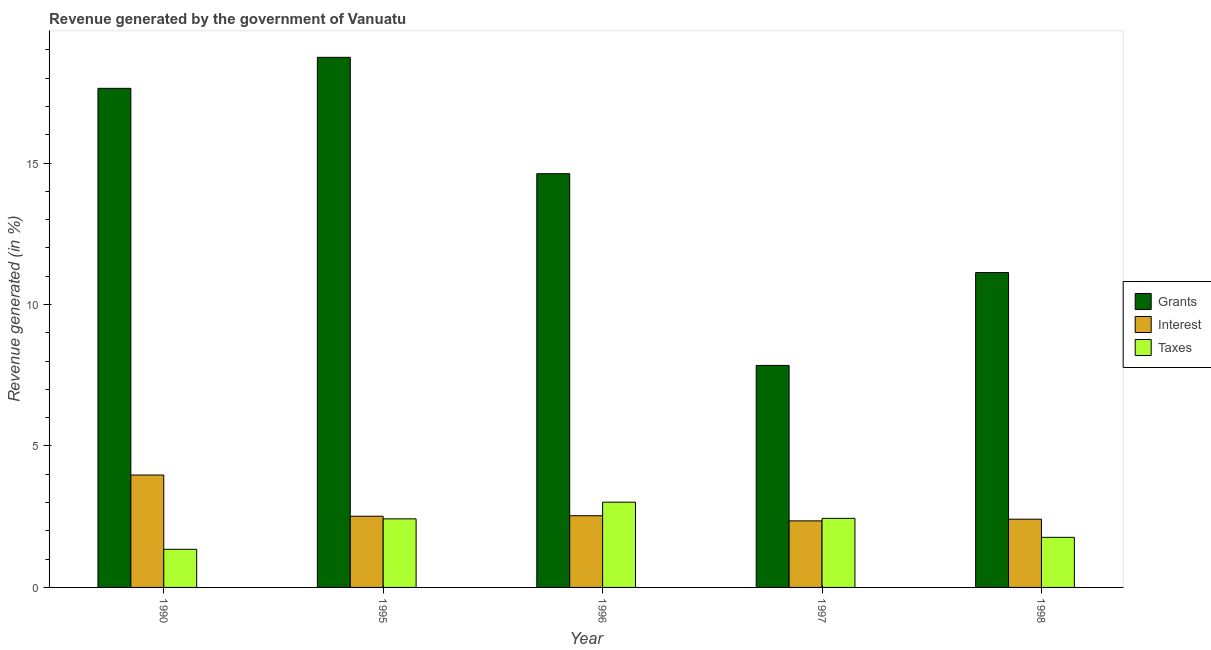Are the number of bars per tick equal to the number of legend labels?
Your answer should be very brief. Yes. How many bars are there on the 3rd tick from the left?
Give a very brief answer. 3. What is the label of the 5th group of bars from the left?
Your response must be concise. 1998. In how many cases, is the number of bars for a given year not equal to the number of legend labels?
Keep it short and to the point. 0. What is the percentage of revenue generated by grants in 1997?
Keep it short and to the point. 7.85. Across all years, what is the maximum percentage of revenue generated by interest?
Keep it short and to the point. 3.97. Across all years, what is the minimum percentage of revenue generated by interest?
Your answer should be compact. 2.35. In which year was the percentage of revenue generated by grants maximum?
Your answer should be compact. 1995. In which year was the percentage of revenue generated by interest minimum?
Your response must be concise. 1997. What is the total percentage of revenue generated by interest in the graph?
Your response must be concise. 13.79. What is the difference between the percentage of revenue generated by grants in 1990 and that in 1996?
Give a very brief answer. 3.02. What is the difference between the percentage of revenue generated by interest in 1998 and the percentage of revenue generated by grants in 1990?
Make the answer very short. -1.56. What is the average percentage of revenue generated by interest per year?
Your answer should be compact. 2.76. In the year 1990, what is the difference between the percentage of revenue generated by taxes and percentage of revenue generated by grants?
Your answer should be very brief. 0. In how many years, is the percentage of revenue generated by interest greater than 18 %?
Offer a terse response. 0. What is the ratio of the percentage of revenue generated by grants in 1997 to that in 1998?
Offer a very short reply. 0.71. Is the difference between the percentage of revenue generated by taxes in 1997 and 1998 greater than the difference between the percentage of revenue generated by grants in 1997 and 1998?
Provide a succinct answer. No. What is the difference between the highest and the second highest percentage of revenue generated by taxes?
Your answer should be compact. 0.57. What is the difference between the highest and the lowest percentage of revenue generated by interest?
Provide a short and direct response. 1.62. In how many years, is the percentage of revenue generated by grants greater than the average percentage of revenue generated by grants taken over all years?
Ensure brevity in your answer.  3. What does the 2nd bar from the left in 1995 represents?
Ensure brevity in your answer.  Interest. What does the 3rd bar from the right in 1990 represents?
Provide a short and direct response. Grants. Is it the case that in every year, the sum of the percentage of revenue generated by grants and percentage of revenue generated by interest is greater than the percentage of revenue generated by taxes?
Give a very brief answer. Yes. Are all the bars in the graph horizontal?
Provide a succinct answer. No. How many years are there in the graph?
Give a very brief answer. 5. What is the difference between two consecutive major ticks on the Y-axis?
Your answer should be compact. 5. Are the values on the major ticks of Y-axis written in scientific E-notation?
Give a very brief answer. No. Does the graph contain grids?
Provide a short and direct response. No. How many legend labels are there?
Your response must be concise. 3. What is the title of the graph?
Ensure brevity in your answer.  Revenue generated by the government of Vanuatu. What is the label or title of the X-axis?
Your answer should be very brief. Year. What is the label or title of the Y-axis?
Provide a succinct answer. Revenue generated (in %). What is the Revenue generated (in %) of Grants in 1990?
Provide a short and direct response. 17.64. What is the Revenue generated (in %) of Interest in 1990?
Your response must be concise. 3.97. What is the Revenue generated (in %) in Taxes in 1990?
Give a very brief answer. 1.35. What is the Revenue generated (in %) of Grants in 1995?
Ensure brevity in your answer.  18.74. What is the Revenue generated (in %) of Interest in 1995?
Your response must be concise. 2.52. What is the Revenue generated (in %) in Taxes in 1995?
Your response must be concise. 2.42. What is the Revenue generated (in %) in Grants in 1996?
Your response must be concise. 14.63. What is the Revenue generated (in %) in Interest in 1996?
Provide a succinct answer. 2.53. What is the Revenue generated (in %) of Taxes in 1996?
Your answer should be very brief. 3.01. What is the Revenue generated (in %) in Grants in 1997?
Provide a short and direct response. 7.85. What is the Revenue generated (in %) of Interest in 1997?
Ensure brevity in your answer.  2.35. What is the Revenue generated (in %) of Taxes in 1997?
Your answer should be compact. 2.44. What is the Revenue generated (in %) in Grants in 1998?
Make the answer very short. 11.13. What is the Revenue generated (in %) in Interest in 1998?
Make the answer very short. 2.41. What is the Revenue generated (in %) in Taxes in 1998?
Provide a short and direct response. 1.77. Across all years, what is the maximum Revenue generated (in %) in Grants?
Your answer should be very brief. 18.74. Across all years, what is the maximum Revenue generated (in %) of Interest?
Keep it short and to the point. 3.97. Across all years, what is the maximum Revenue generated (in %) in Taxes?
Your answer should be very brief. 3.01. Across all years, what is the minimum Revenue generated (in %) of Grants?
Provide a short and direct response. 7.85. Across all years, what is the minimum Revenue generated (in %) in Interest?
Provide a succinct answer. 2.35. Across all years, what is the minimum Revenue generated (in %) of Taxes?
Give a very brief answer. 1.35. What is the total Revenue generated (in %) in Grants in the graph?
Your answer should be very brief. 69.99. What is the total Revenue generated (in %) in Interest in the graph?
Provide a short and direct response. 13.79. What is the total Revenue generated (in %) in Taxes in the graph?
Provide a succinct answer. 11. What is the difference between the Revenue generated (in %) of Grants in 1990 and that in 1995?
Your answer should be compact. -1.1. What is the difference between the Revenue generated (in %) in Interest in 1990 and that in 1995?
Your answer should be very brief. 1.46. What is the difference between the Revenue generated (in %) of Taxes in 1990 and that in 1995?
Make the answer very short. -1.08. What is the difference between the Revenue generated (in %) in Grants in 1990 and that in 1996?
Make the answer very short. 3.02. What is the difference between the Revenue generated (in %) in Interest in 1990 and that in 1996?
Ensure brevity in your answer.  1.44. What is the difference between the Revenue generated (in %) in Taxes in 1990 and that in 1996?
Keep it short and to the point. -1.67. What is the difference between the Revenue generated (in %) of Grants in 1990 and that in 1997?
Provide a short and direct response. 9.8. What is the difference between the Revenue generated (in %) of Interest in 1990 and that in 1997?
Provide a succinct answer. 1.62. What is the difference between the Revenue generated (in %) in Taxes in 1990 and that in 1997?
Provide a short and direct response. -1.09. What is the difference between the Revenue generated (in %) of Grants in 1990 and that in 1998?
Provide a short and direct response. 6.51. What is the difference between the Revenue generated (in %) of Interest in 1990 and that in 1998?
Your answer should be compact. 1.56. What is the difference between the Revenue generated (in %) of Taxes in 1990 and that in 1998?
Offer a terse response. -0.42. What is the difference between the Revenue generated (in %) of Grants in 1995 and that in 1996?
Give a very brief answer. 4.11. What is the difference between the Revenue generated (in %) of Interest in 1995 and that in 1996?
Your answer should be compact. -0.02. What is the difference between the Revenue generated (in %) of Taxes in 1995 and that in 1996?
Make the answer very short. -0.59. What is the difference between the Revenue generated (in %) of Grants in 1995 and that in 1997?
Your response must be concise. 10.89. What is the difference between the Revenue generated (in %) in Interest in 1995 and that in 1997?
Provide a succinct answer. 0.16. What is the difference between the Revenue generated (in %) in Taxes in 1995 and that in 1997?
Offer a very short reply. -0.02. What is the difference between the Revenue generated (in %) in Grants in 1995 and that in 1998?
Keep it short and to the point. 7.61. What is the difference between the Revenue generated (in %) in Interest in 1995 and that in 1998?
Ensure brevity in your answer.  0.11. What is the difference between the Revenue generated (in %) in Taxes in 1995 and that in 1998?
Offer a terse response. 0.65. What is the difference between the Revenue generated (in %) of Grants in 1996 and that in 1997?
Your answer should be very brief. 6.78. What is the difference between the Revenue generated (in %) of Interest in 1996 and that in 1997?
Keep it short and to the point. 0.18. What is the difference between the Revenue generated (in %) in Taxes in 1996 and that in 1997?
Give a very brief answer. 0.57. What is the difference between the Revenue generated (in %) of Grants in 1996 and that in 1998?
Ensure brevity in your answer.  3.49. What is the difference between the Revenue generated (in %) in Interest in 1996 and that in 1998?
Provide a succinct answer. 0.12. What is the difference between the Revenue generated (in %) of Taxes in 1996 and that in 1998?
Make the answer very short. 1.24. What is the difference between the Revenue generated (in %) in Grants in 1997 and that in 1998?
Keep it short and to the point. -3.28. What is the difference between the Revenue generated (in %) in Interest in 1997 and that in 1998?
Your answer should be compact. -0.06. What is the difference between the Revenue generated (in %) in Taxes in 1997 and that in 1998?
Your answer should be compact. 0.67. What is the difference between the Revenue generated (in %) of Grants in 1990 and the Revenue generated (in %) of Interest in 1995?
Ensure brevity in your answer.  15.13. What is the difference between the Revenue generated (in %) of Grants in 1990 and the Revenue generated (in %) of Taxes in 1995?
Offer a very short reply. 15.22. What is the difference between the Revenue generated (in %) of Interest in 1990 and the Revenue generated (in %) of Taxes in 1995?
Ensure brevity in your answer.  1.55. What is the difference between the Revenue generated (in %) in Grants in 1990 and the Revenue generated (in %) in Interest in 1996?
Provide a short and direct response. 15.11. What is the difference between the Revenue generated (in %) of Grants in 1990 and the Revenue generated (in %) of Taxes in 1996?
Provide a succinct answer. 14.63. What is the difference between the Revenue generated (in %) of Interest in 1990 and the Revenue generated (in %) of Taxes in 1996?
Offer a terse response. 0.96. What is the difference between the Revenue generated (in %) of Grants in 1990 and the Revenue generated (in %) of Interest in 1997?
Provide a succinct answer. 15.29. What is the difference between the Revenue generated (in %) of Grants in 1990 and the Revenue generated (in %) of Taxes in 1997?
Give a very brief answer. 15.2. What is the difference between the Revenue generated (in %) in Interest in 1990 and the Revenue generated (in %) in Taxes in 1997?
Ensure brevity in your answer.  1.53. What is the difference between the Revenue generated (in %) of Grants in 1990 and the Revenue generated (in %) of Interest in 1998?
Ensure brevity in your answer.  15.23. What is the difference between the Revenue generated (in %) of Grants in 1990 and the Revenue generated (in %) of Taxes in 1998?
Keep it short and to the point. 15.87. What is the difference between the Revenue generated (in %) of Interest in 1990 and the Revenue generated (in %) of Taxes in 1998?
Your response must be concise. 2.2. What is the difference between the Revenue generated (in %) in Grants in 1995 and the Revenue generated (in %) in Interest in 1996?
Your response must be concise. 16.21. What is the difference between the Revenue generated (in %) of Grants in 1995 and the Revenue generated (in %) of Taxes in 1996?
Ensure brevity in your answer.  15.73. What is the difference between the Revenue generated (in %) of Interest in 1995 and the Revenue generated (in %) of Taxes in 1996?
Offer a very short reply. -0.5. What is the difference between the Revenue generated (in %) of Grants in 1995 and the Revenue generated (in %) of Interest in 1997?
Give a very brief answer. 16.39. What is the difference between the Revenue generated (in %) in Grants in 1995 and the Revenue generated (in %) in Taxes in 1997?
Your answer should be compact. 16.3. What is the difference between the Revenue generated (in %) of Interest in 1995 and the Revenue generated (in %) of Taxes in 1997?
Give a very brief answer. 0.08. What is the difference between the Revenue generated (in %) in Grants in 1995 and the Revenue generated (in %) in Interest in 1998?
Give a very brief answer. 16.33. What is the difference between the Revenue generated (in %) in Grants in 1995 and the Revenue generated (in %) in Taxes in 1998?
Keep it short and to the point. 16.97. What is the difference between the Revenue generated (in %) of Interest in 1995 and the Revenue generated (in %) of Taxes in 1998?
Your answer should be compact. 0.75. What is the difference between the Revenue generated (in %) of Grants in 1996 and the Revenue generated (in %) of Interest in 1997?
Provide a short and direct response. 12.27. What is the difference between the Revenue generated (in %) in Grants in 1996 and the Revenue generated (in %) in Taxes in 1997?
Provide a succinct answer. 12.18. What is the difference between the Revenue generated (in %) of Interest in 1996 and the Revenue generated (in %) of Taxes in 1997?
Provide a short and direct response. 0.09. What is the difference between the Revenue generated (in %) in Grants in 1996 and the Revenue generated (in %) in Interest in 1998?
Provide a short and direct response. 12.21. What is the difference between the Revenue generated (in %) of Grants in 1996 and the Revenue generated (in %) of Taxes in 1998?
Give a very brief answer. 12.85. What is the difference between the Revenue generated (in %) in Interest in 1996 and the Revenue generated (in %) in Taxes in 1998?
Provide a short and direct response. 0.76. What is the difference between the Revenue generated (in %) in Grants in 1997 and the Revenue generated (in %) in Interest in 1998?
Keep it short and to the point. 5.44. What is the difference between the Revenue generated (in %) in Grants in 1997 and the Revenue generated (in %) in Taxes in 1998?
Provide a succinct answer. 6.08. What is the difference between the Revenue generated (in %) of Interest in 1997 and the Revenue generated (in %) of Taxes in 1998?
Ensure brevity in your answer.  0.58. What is the average Revenue generated (in %) in Grants per year?
Offer a terse response. 14. What is the average Revenue generated (in %) of Interest per year?
Offer a terse response. 2.76. What is the average Revenue generated (in %) in Taxes per year?
Give a very brief answer. 2.2. In the year 1990, what is the difference between the Revenue generated (in %) in Grants and Revenue generated (in %) in Interest?
Your response must be concise. 13.67. In the year 1990, what is the difference between the Revenue generated (in %) of Grants and Revenue generated (in %) of Taxes?
Ensure brevity in your answer.  16.3. In the year 1990, what is the difference between the Revenue generated (in %) in Interest and Revenue generated (in %) in Taxes?
Give a very brief answer. 2.63. In the year 1995, what is the difference between the Revenue generated (in %) in Grants and Revenue generated (in %) in Interest?
Keep it short and to the point. 16.22. In the year 1995, what is the difference between the Revenue generated (in %) of Grants and Revenue generated (in %) of Taxes?
Your answer should be very brief. 16.32. In the year 1995, what is the difference between the Revenue generated (in %) in Interest and Revenue generated (in %) in Taxes?
Give a very brief answer. 0.09. In the year 1996, what is the difference between the Revenue generated (in %) in Grants and Revenue generated (in %) in Interest?
Offer a terse response. 12.09. In the year 1996, what is the difference between the Revenue generated (in %) of Grants and Revenue generated (in %) of Taxes?
Make the answer very short. 11.61. In the year 1996, what is the difference between the Revenue generated (in %) of Interest and Revenue generated (in %) of Taxes?
Make the answer very short. -0.48. In the year 1997, what is the difference between the Revenue generated (in %) of Grants and Revenue generated (in %) of Interest?
Your answer should be compact. 5.5. In the year 1997, what is the difference between the Revenue generated (in %) in Grants and Revenue generated (in %) in Taxes?
Your answer should be compact. 5.41. In the year 1997, what is the difference between the Revenue generated (in %) in Interest and Revenue generated (in %) in Taxes?
Your answer should be very brief. -0.09. In the year 1998, what is the difference between the Revenue generated (in %) in Grants and Revenue generated (in %) in Interest?
Give a very brief answer. 8.72. In the year 1998, what is the difference between the Revenue generated (in %) of Grants and Revenue generated (in %) of Taxes?
Give a very brief answer. 9.36. In the year 1998, what is the difference between the Revenue generated (in %) in Interest and Revenue generated (in %) in Taxes?
Make the answer very short. 0.64. What is the ratio of the Revenue generated (in %) in Grants in 1990 to that in 1995?
Keep it short and to the point. 0.94. What is the ratio of the Revenue generated (in %) in Interest in 1990 to that in 1995?
Give a very brief answer. 1.58. What is the ratio of the Revenue generated (in %) in Taxes in 1990 to that in 1995?
Offer a very short reply. 0.56. What is the ratio of the Revenue generated (in %) in Grants in 1990 to that in 1996?
Offer a very short reply. 1.21. What is the ratio of the Revenue generated (in %) in Interest in 1990 to that in 1996?
Make the answer very short. 1.57. What is the ratio of the Revenue generated (in %) of Taxes in 1990 to that in 1996?
Make the answer very short. 0.45. What is the ratio of the Revenue generated (in %) of Grants in 1990 to that in 1997?
Make the answer very short. 2.25. What is the ratio of the Revenue generated (in %) in Interest in 1990 to that in 1997?
Your response must be concise. 1.69. What is the ratio of the Revenue generated (in %) in Taxes in 1990 to that in 1997?
Provide a succinct answer. 0.55. What is the ratio of the Revenue generated (in %) in Grants in 1990 to that in 1998?
Your response must be concise. 1.59. What is the ratio of the Revenue generated (in %) of Interest in 1990 to that in 1998?
Provide a succinct answer. 1.65. What is the ratio of the Revenue generated (in %) of Taxes in 1990 to that in 1998?
Your answer should be compact. 0.76. What is the ratio of the Revenue generated (in %) of Grants in 1995 to that in 1996?
Give a very brief answer. 1.28. What is the ratio of the Revenue generated (in %) of Interest in 1995 to that in 1996?
Your response must be concise. 0.99. What is the ratio of the Revenue generated (in %) in Taxes in 1995 to that in 1996?
Offer a very short reply. 0.8. What is the ratio of the Revenue generated (in %) in Grants in 1995 to that in 1997?
Your response must be concise. 2.39. What is the ratio of the Revenue generated (in %) of Interest in 1995 to that in 1997?
Make the answer very short. 1.07. What is the ratio of the Revenue generated (in %) of Taxes in 1995 to that in 1997?
Keep it short and to the point. 0.99. What is the ratio of the Revenue generated (in %) in Grants in 1995 to that in 1998?
Your answer should be very brief. 1.68. What is the ratio of the Revenue generated (in %) in Interest in 1995 to that in 1998?
Offer a terse response. 1.04. What is the ratio of the Revenue generated (in %) in Taxes in 1995 to that in 1998?
Offer a very short reply. 1.37. What is the ratio of the Revenue generated (in %) of Grants in 1996 to that in 1997?
Your answer should be compact. 1.86. What is the ratio of the Revenue generated (in %) in Interest in 1996 to that in 1997?
Your answer should be compact. 1.08. What is the ratio of the Revenue generated (in %) in Taxes in 1996 to that in 1997?
Provide a short and direct response. 1.23. What is the ratio of the Revenue generated (in %) of Grants in 1996 to that in 1998?
Your answer should be compact. 1.31. What is the ratio of the Revenue generated (in %) in Interest in 1996 to that in 1998?
Give a very brief answer. 1.05. What is the ratio of the Revenue generated (in %) of Taxes in 1996 to that in 1998?
Give a very brief answer. 1.7. What is the ratio of the Revenue generated (in %) of Grants in 1997 to that in 1998?
Your answer should be very brief. 0.71. What is the ratio of the Revenue generated (in %) of Interest in 1997 to that in 1998?
Your answer should be very brief. 0.98. What is the ratio of the Revenue generated (in %) in Taxes in 1997 to that in 1998?
Provide a succinct answer. 1.38. What is the difference between the highest and the second highest Revenue generated (in %) of Grants?
Your answer should be very brief. 1.1. What is the difference between the highest and the second highest Revenue generated (in %) in Interest?
Your answer should be compact. 1.44. What is the difference between the highest and the second highest Revenue generated (in %) of Taxes?
Your answer should be very brief. 0.57. What is the difference between the highest and the lowest Revenue generated (in %) in Grants?
Offer a terse response. 10.89. What is the difference between the highest and the lowest Revenue generated (in %) in Interest?
Ensure brevity in your answer.  1.62. What is the difference between the highest and the lowest Revenue generated (in %) of Taxes?
Ensure brevity in your answer.  1.67. 